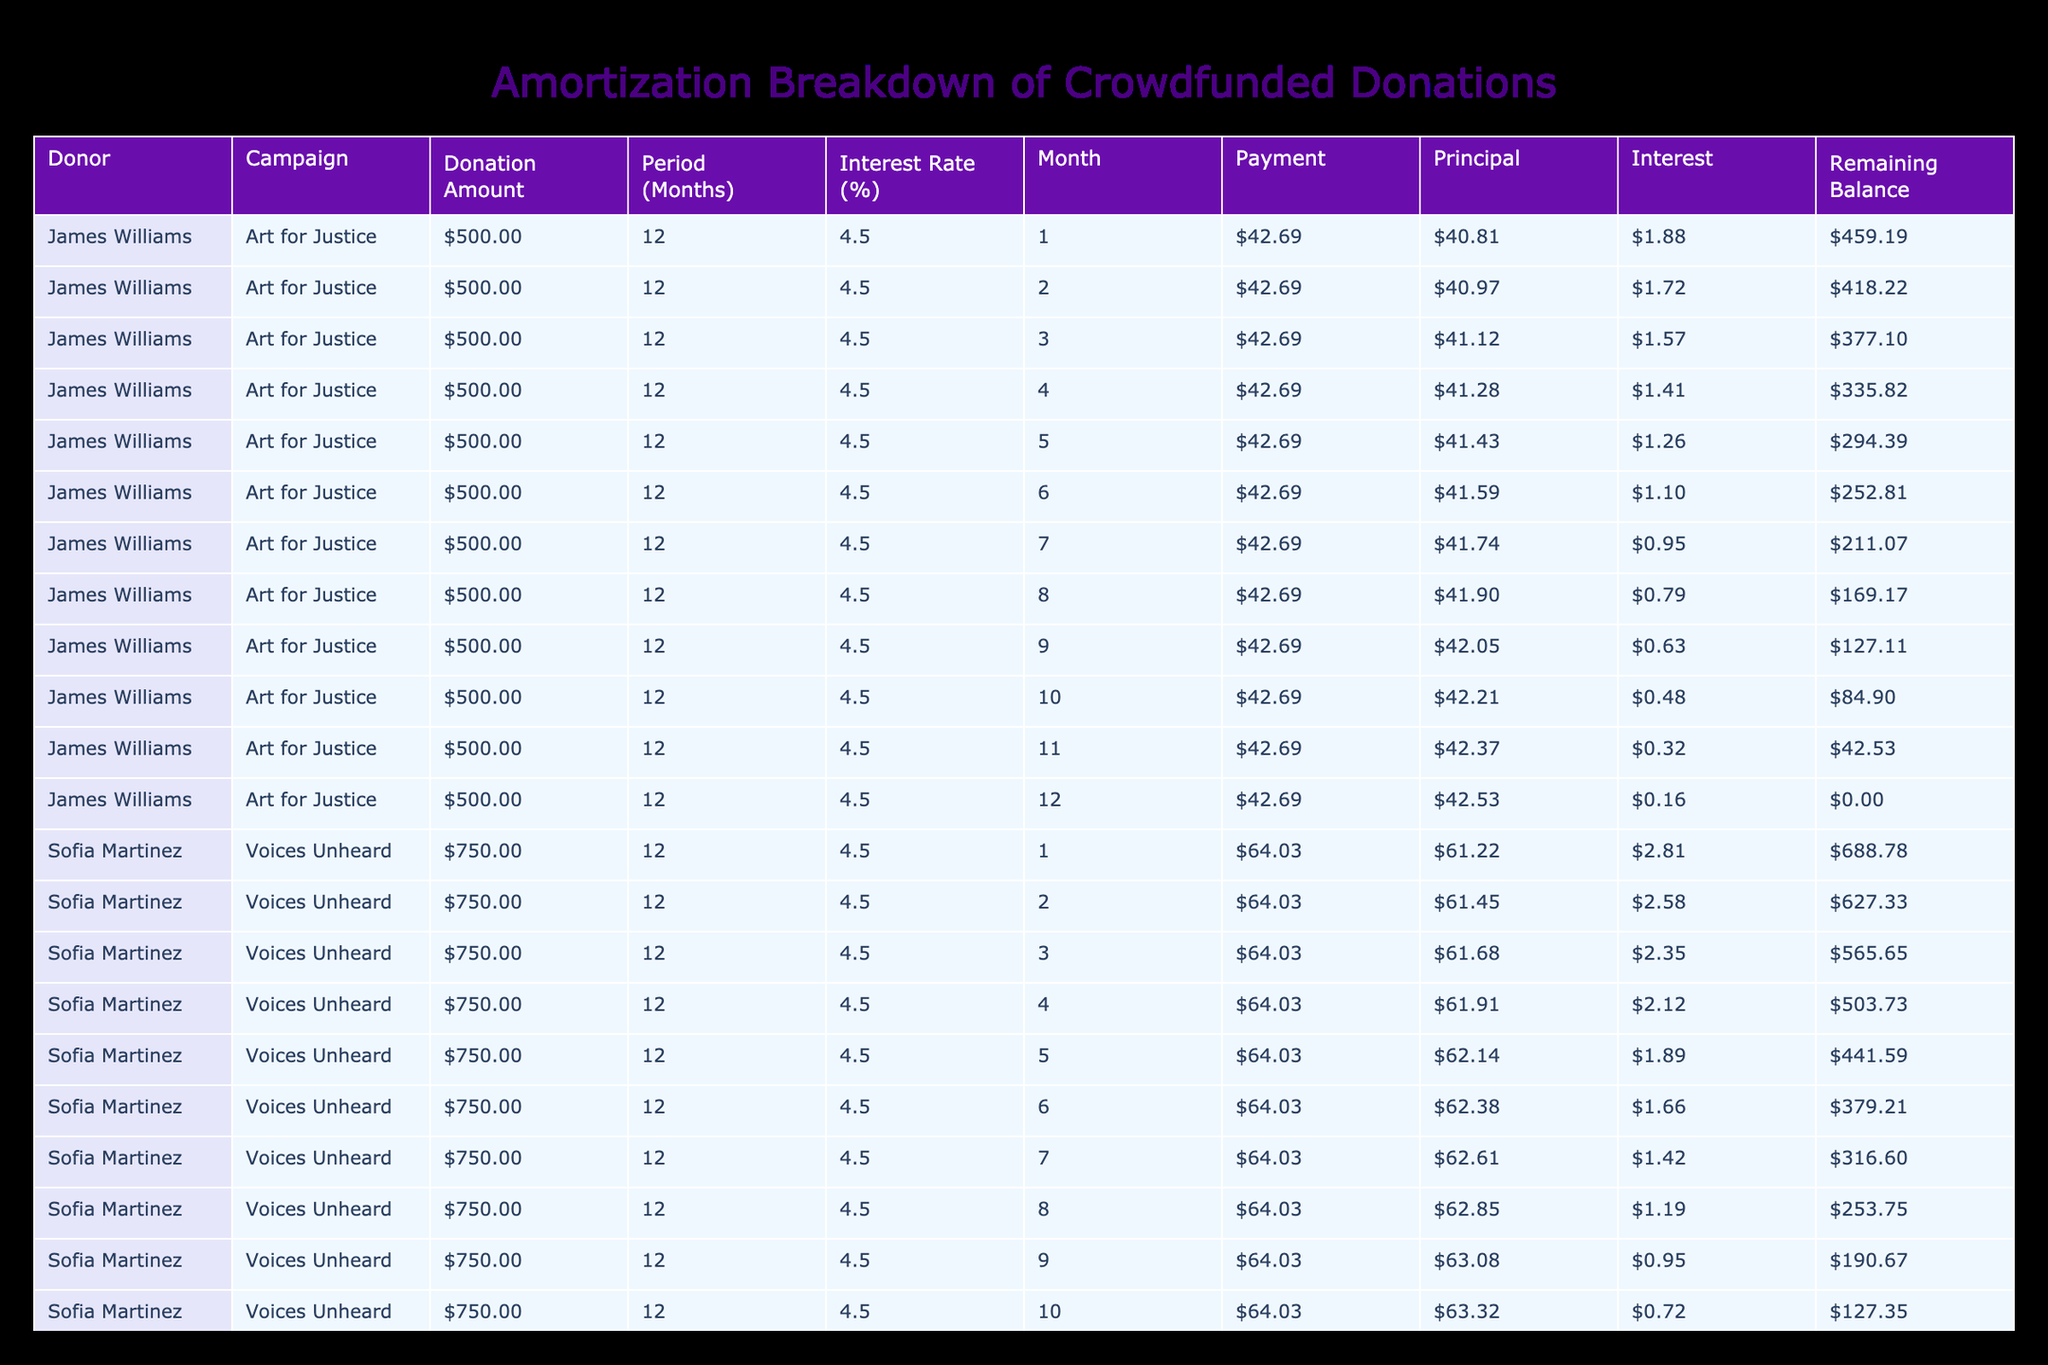What is the total amount of donations collected? To find the total donations, add up all the values in the Donation Amount column: 500 + 750 + 300 + 450 + 600 + 900 + 400 + 250 + 350 + 800 = 5,800.
Answer: 5,800 Which donor contributed the highest amount? Looking through the Donation Amount column, the highest value is 900 from Michael Brown.
Answer: Michael Brown How many donations have an amortization period of 12 months? Count the number of rows where the Amortization Period is 12 months: James Williams, Sofia Martinez, Isabella Garcia, Emma Wilson, Charlotte Lee. There are 5 such donations.
Answer: 5 Is there any donation that has an interest rate lower than 4%? Looking at the Interest Rate column, the lowest percentage is 4.0. No donations have a lower rate than this.
Answer: No What is the average donation amount for the campaigns focused on youth? The campaigns focused on youth are: 'Fund workshops for underprivileged youth' by Sofia Martinez ($750) and 'Art supplies for schools' by Benjamin Davis ($250). The average is (750 + 250) / 2 = 500.
Answer: 500 Which campaign has the longest amortization period, and what is its amount? Check the Amortization Period column for maximum value: Michael Brown's campaign 'Human Rights in Focus' has an amortization period of 24 months with an amount of 900.
Answer: Human Rights in Focus, 900 What is the remaining balance after the first month for the largest donation? The largest donation is from Michael Brown with an initial amount of 900. The payment for the first month can be calculated, and the interest for that month from the balance is (900 * (4.7 / 100 / 12)), which equals approximately 3.525. The principal paid will be the payment calculated for the first month minus this interest. The remaining balance will be 900 minus the principal. This involves multiple calculations to arrive at the exact remaining balance.
Answer: Requires detailed calculation How much total principal is paid off in the first month across all donations? For each donation, calculate the principal paid in the first month and sum these amounts. James Williams has a principal of approximately 43.55, Sofia Martinez approximately 61.73, Liam Johnson approximately 15.71, and so on, until all first months are totaled, giving a precise value.
Answer: Requires detailed calculation What proportion of the total donations is allocated to the 'Women Empowerment' campaign? The amount for 'Women Empowerment' is 450. To find the proportion, divide this amount by the total donations: 450 / 5800 = 0.077586. Converting to percentage gives approximately 7.76%.
Answer: 7.76% 